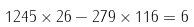Convert formula to latex. <formula><loc_0><loc_0><loc_500><loc_500>1 2 4 5 \times 2 6 - 2 7 9 \times 1 1 6 = 6</formula> 